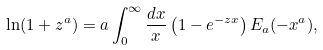<formula> <loc_0><loc_0><loc_500><loc_500>\ln ( 1 + z ^ { a } ) = a \int _ { 0 } ^ { \infty } \frac { d x } x \left ( 1 - e ^ { - z x } \right ) E _ { a } ( - x ^ { a } ) ,</formula> 